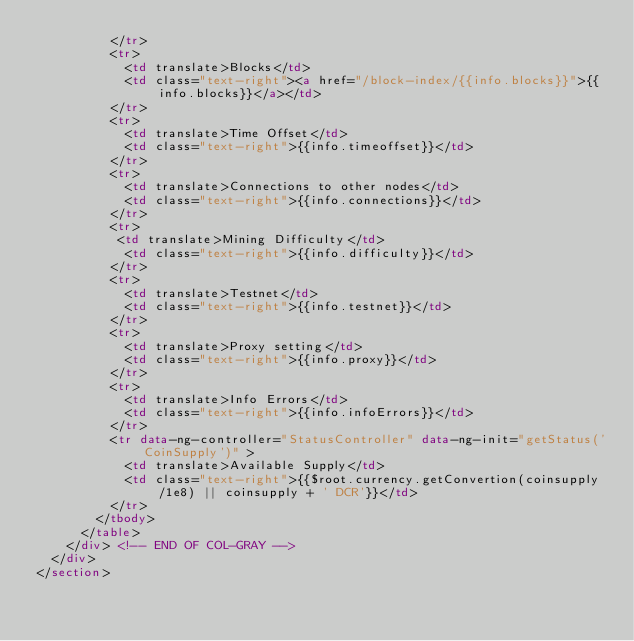<code> <loc_0><loc_0><loc_500><loc_500><_HTML_>          </tr>
          <tr>
            <td translate>Blocks</td>
            <td class="text-right"><a href="/block-index/{{info.blocks}}">{{info.blocks}}</a></td>
          </tr>
          <tr>
            <td translate>Time Offset</td>
            <td class="text-right">{{info.timeoffset}}</td>
          </tr>
          <tr>
            <td translate>Connections to other nodes</td>
            <td class="text-right">{{info.connections}}</td>
          </tr>
          <tr>
           <td translate>Mining Difficulty</td>
            <td class="text-right">{{info.difficulty}}</td>
          </tr>
          <tr>
            <td translate>Testnet</td>
            <td class="text-right">{{info.testnet}}</td>
          </tr>
          <tr>
            <td translate>Proxy setting</td>
            <td class="text-right">{{info.proxy}}</td>
          </tr>
          <tr>
            <td translate>Info Errors</td>
            <td class="text-right">{{info.infoErrors}}</td>
          </tr>
          <tr data-ng-controller="StatusController" data-ng-init="getStatus('CoinSupply')" >
            <td translate>Available Supply</td>
            <td class="text-right">{{$root.currency.getConvertion(coinsupply/1e8) || coinsupply + ' DCR'}}</td>
          </tr>
        </tbody>
      </table>
    </div> <!-- END OF COL-GRAY -->
  </div>
</section>

</code> 